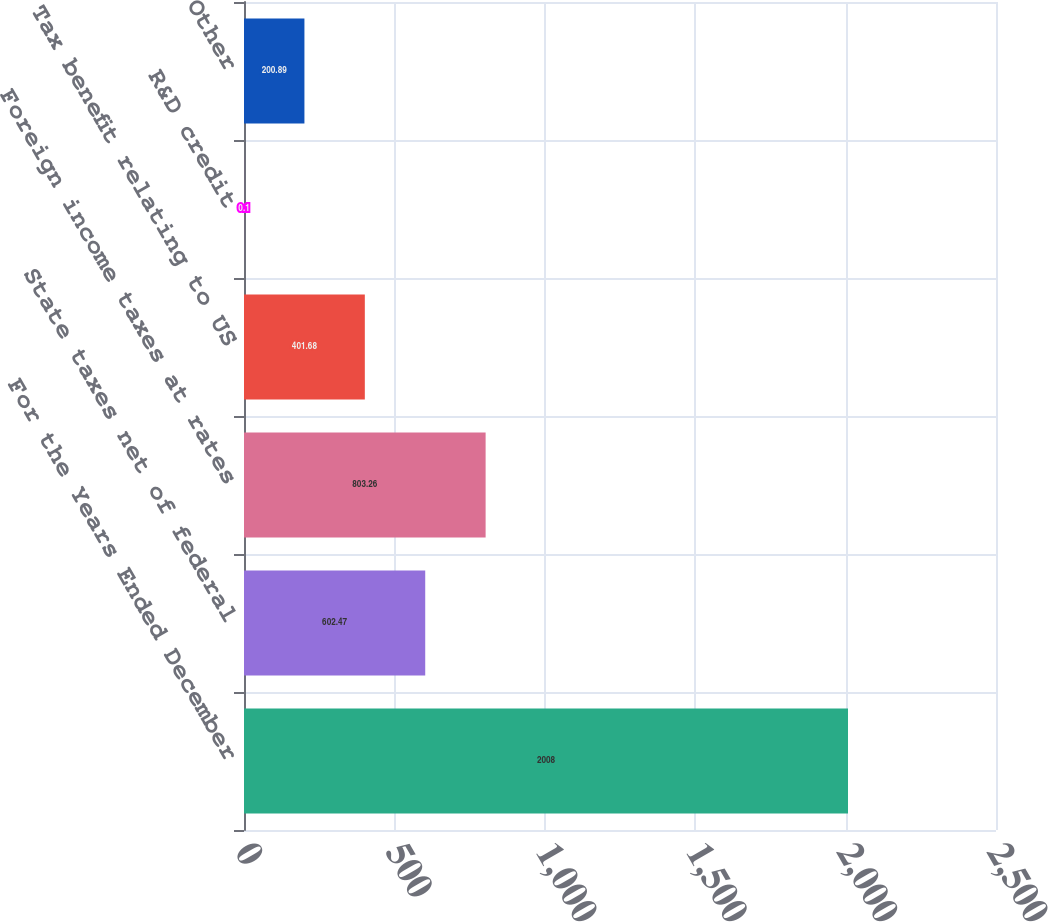Convert chart. <chart><loc_0><loc_0><loc_500><loc_500><bar_chart><fcel>For the Years Ended December<fcel>State taxes net of federal<fcel>Foreign income taxes at rates<fcel>Tax benefit relating to US<fcel>R&D credit<fcel>Other<nl><fcel>2008<fcel>602.47<fcel>803.26<fcel>401.68<fcel>0.1<fcel>200.89<nl></chart> 